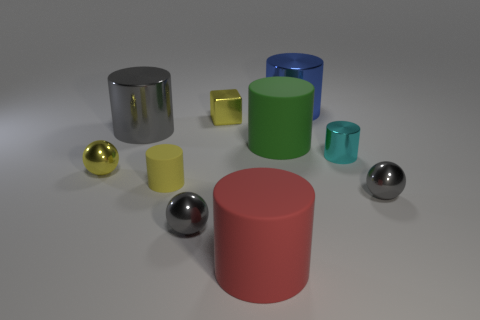Do the small ball that is left of the yellow matte object and the small cyan cylinder in front of the big gray metallic cylinder have the same material?
Offer a terse response. Yes. Are there more gray balls than rubber things?
Your answer should be very brief. No. Are there any other things that are the same color as the shiny cube?
Your answer should be very brief. Yes. Is the material of the large green thing the same as the tiny cube?
Keep it short and to the point. No. Is the number of tiny yellow metal blocks less than the number of small purple matte cylinders?
Your answer should be very brief. No. What color is the tiny cube?
Make the answer very short. Yellow. What number of other objects are there of the same material as the small cyan cylinder?
Keep it short and to the point. 6. What number of red objects are either large cylinders or large metal objects?
Ensure brevity in your answer.  1. Does the large green thing in front of the big gray metal cylinder have the same shape as the large thing that is in front of the tiny matte cylinder?
Offer a terse response. Yes. Does the tiny matte thing have the same color as the tiny metal block behind the tiny yellow ball?
Ensure brevity in your answer.  Yes. 